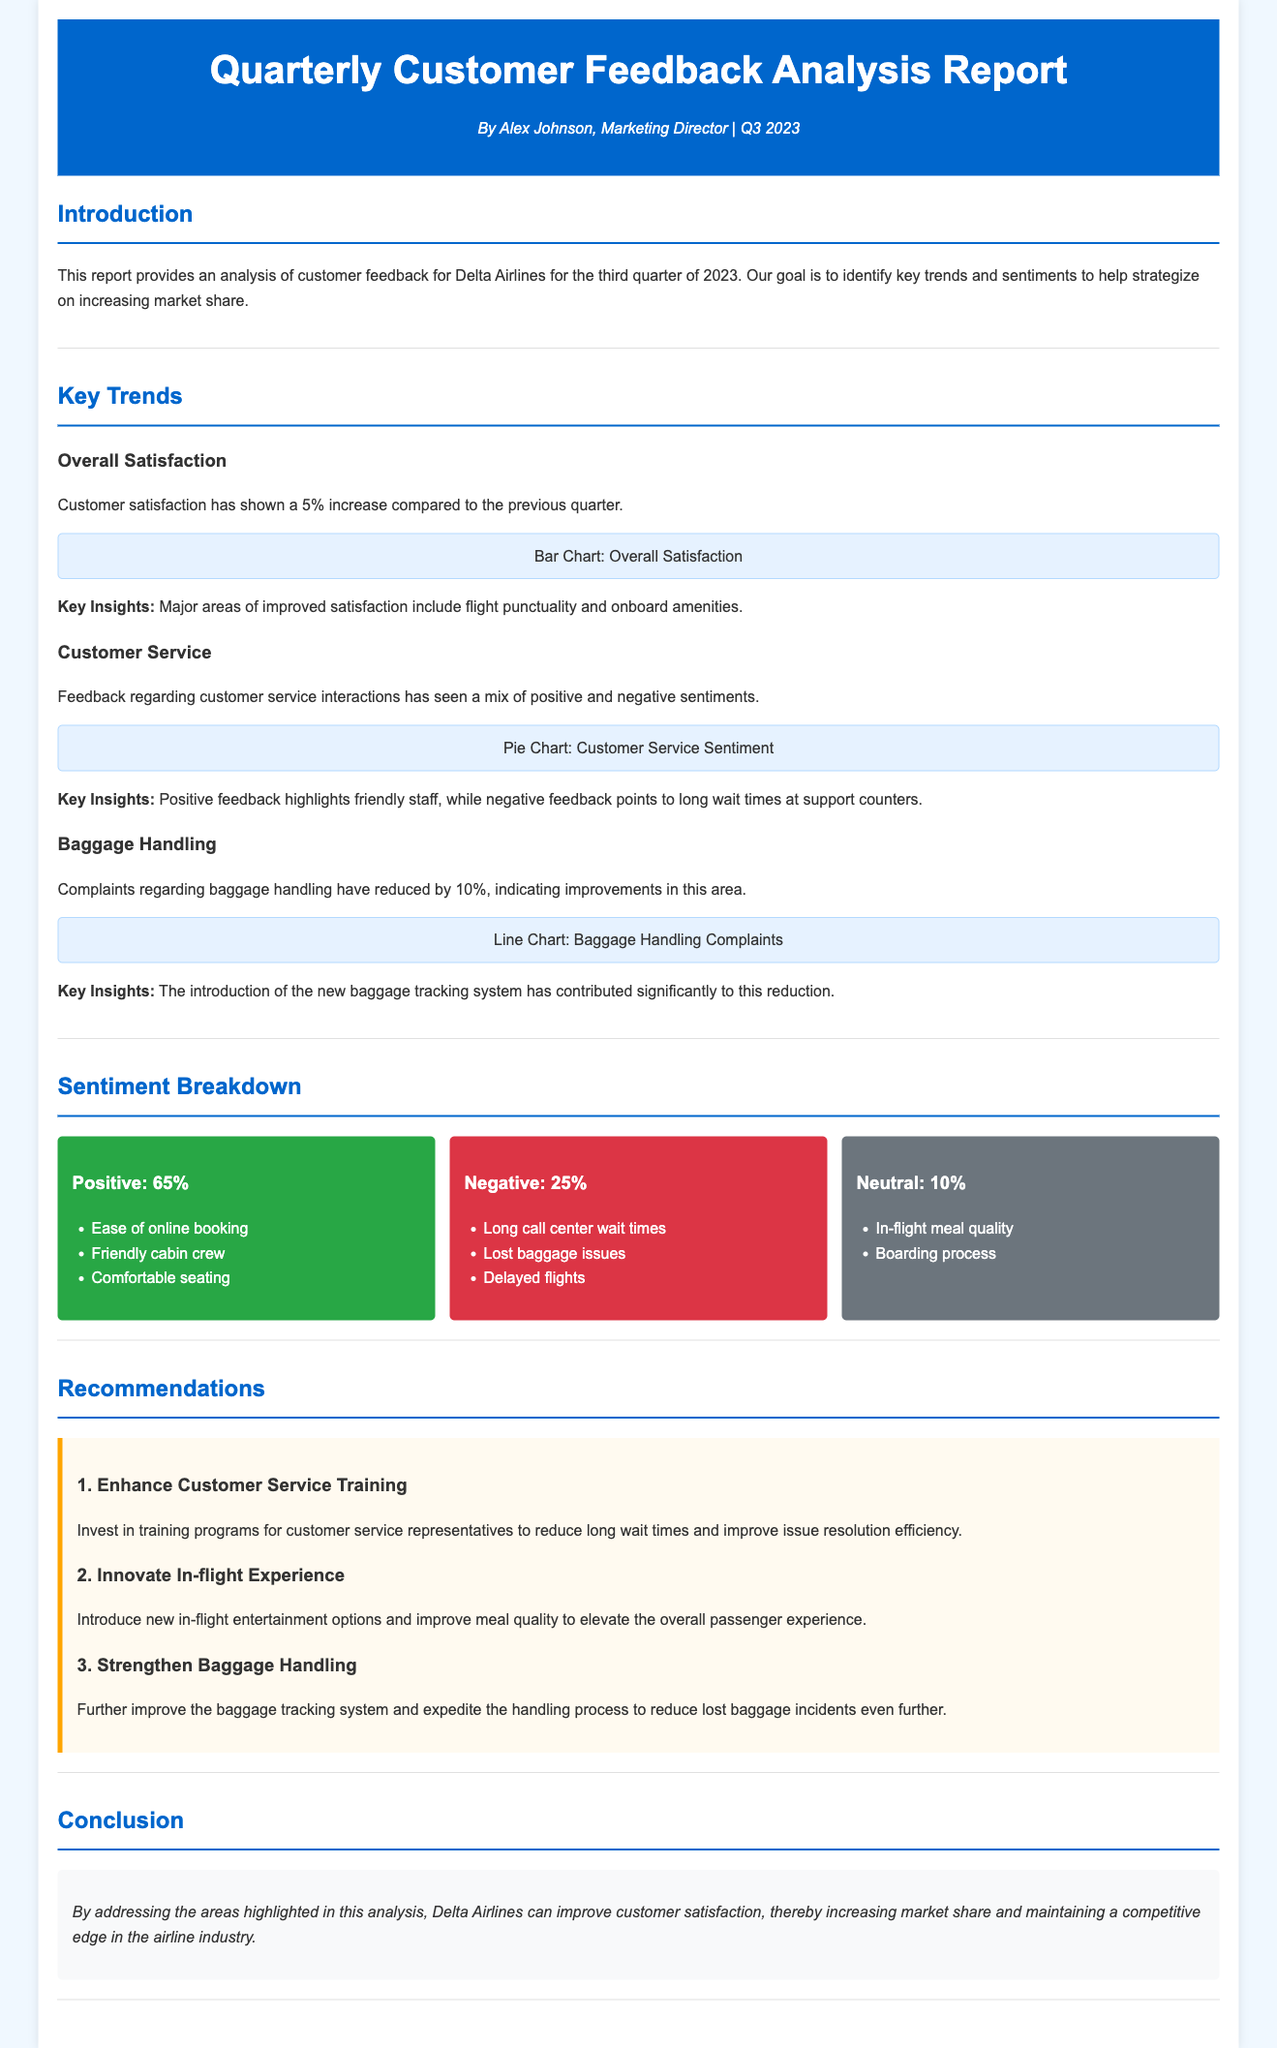What percentage increase in customer satisfaction was reported? The report states that customer satisfaction has shown a 5% increase compared to the previous quarter.
Answer: 5% What is the positive sentiment percentage among customer feedback? The document includes a sentiment breakdown, which shows that positive sentiment is at 65%.
Answer: 65% What are the major complaints highlighted in the negative sentiment? The negative sentiment section lists long call center wait times, lost baggage issues, and delayed flights as complaints.
Answer: Long call center wait times, lost baggage issues, and delayed flights Which area saw a 10% reduction in complaints? The report notes a 10% reduction in complaints regarding baggage handling.
Answer: Baggage handling What recommendation is made to enhance the customer experience? The recommendations section suggests investing in training programs for customer service representatives.
Answer: Enhance Customer Service Training What new feature contributed to reducing baggage handling complaints? The introduction of a new baggage tracking system is credited with significantly reducing complaints.
Answer: New baggage tracking system What aspect of customer service received positive feedback? The report states that friendly staff was a highlight of positive feedback in customer service interactions.
Answer: Friendly staff What is included in the neutral sentiment category? The neutral sentiment section lists in-flight meal quality and boarding process as items in that category.
Answer: In-flight meal quality and boarding process 